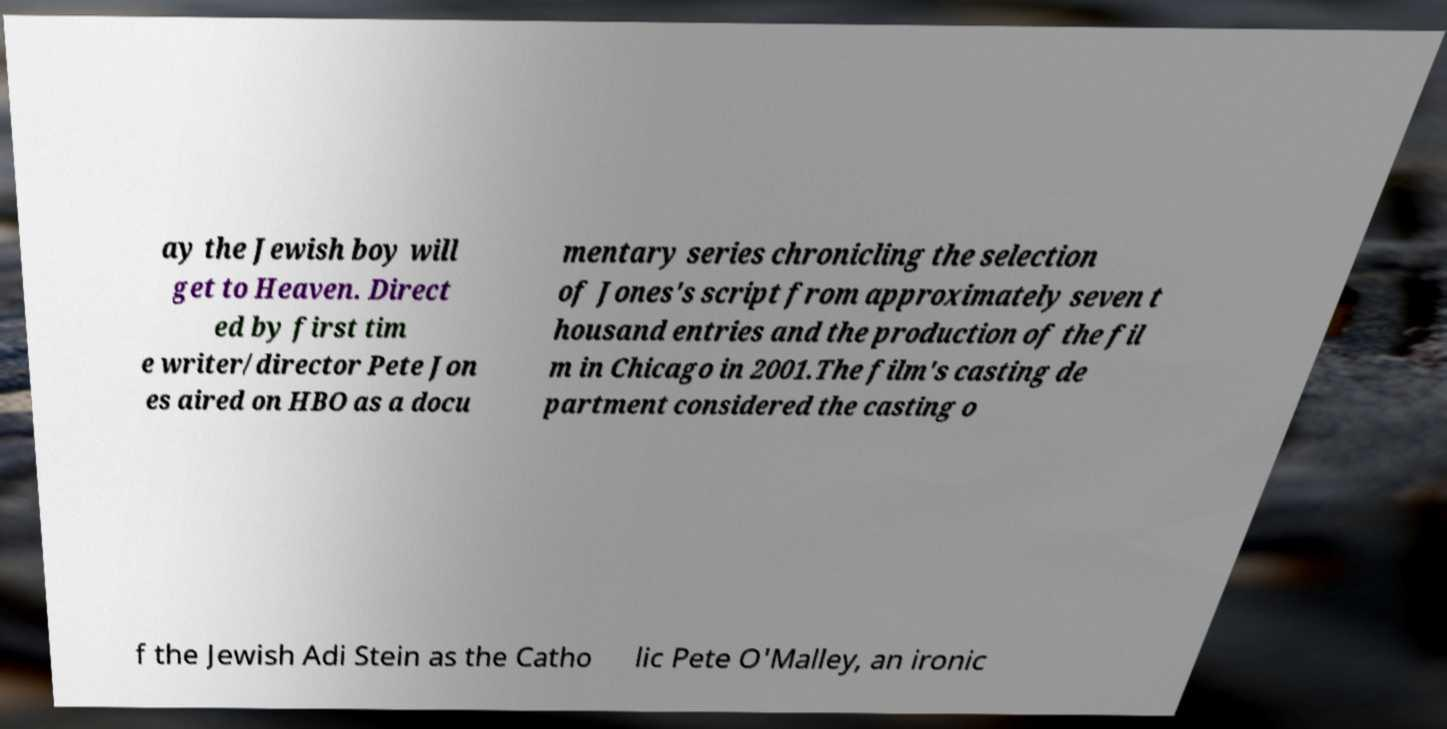Please read and relay the text visible in this image. What does it say? ay the Jewish boy will get to Heaven. Direct ed by first tim e writer/director Pete Jon es aired on HBO as a docu mentary series chronicling the selection of Jones's script from approximately seven t housand entries and the production of the fil m in Chicago in 2001.The film's casting de partment considered the casting o f the Jewish Adi Stein as the Catho lic Pete O'Malley, an ironic 